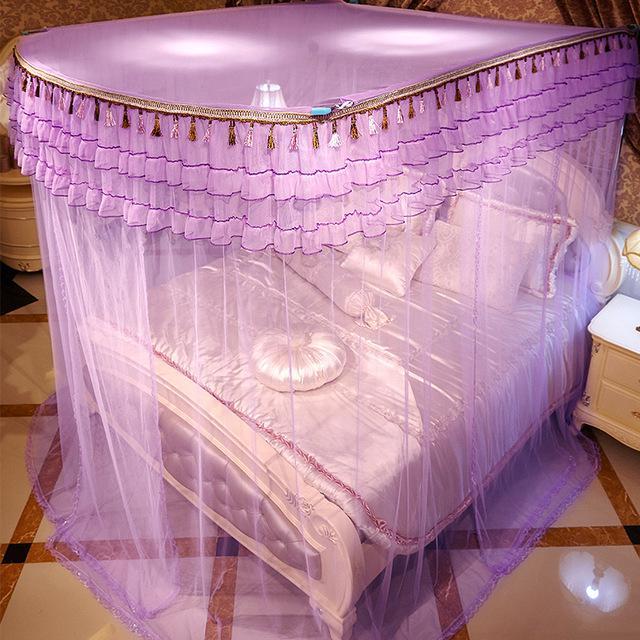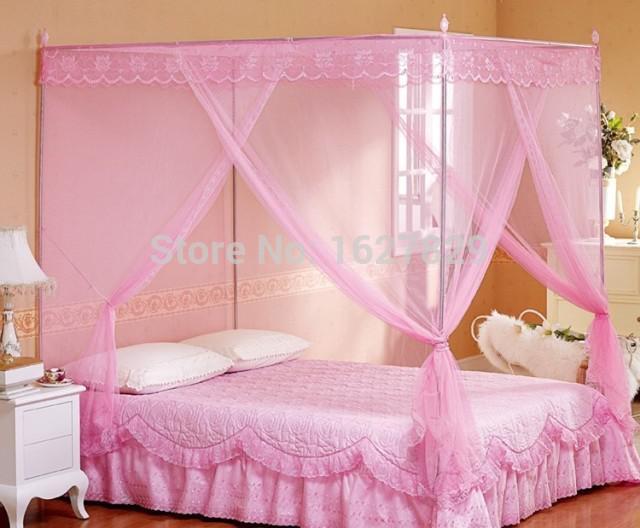The first image is the image on the left, the second image is the image on the right. Analyze the images presented: Is the assertion "There are two canopies with at least one that is purple." valid? Answer yes or no. Yes. The first image is the image on the left, the second image is the image on the right. For the images displayed, is the sentence "One of the beds is a bunk bed." factually correct? Answer yes or no. No. 